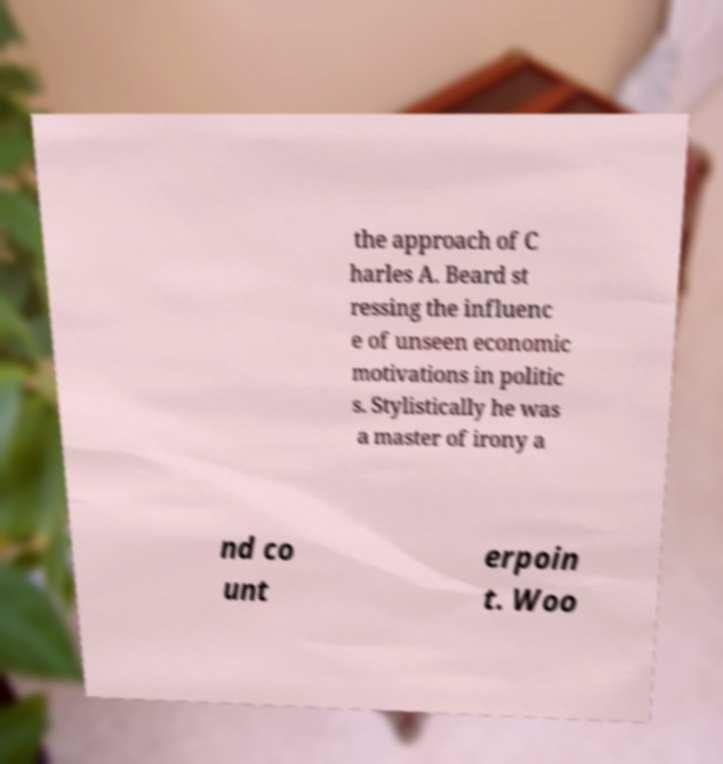Can you accurately transcribe the text from the provided image for me? the approach of C harles A. Beard st ressing the influenc e of unseen economic motivations in politic s. Stylistically he was a master of irony a nd co unt erpoin t. Woo 